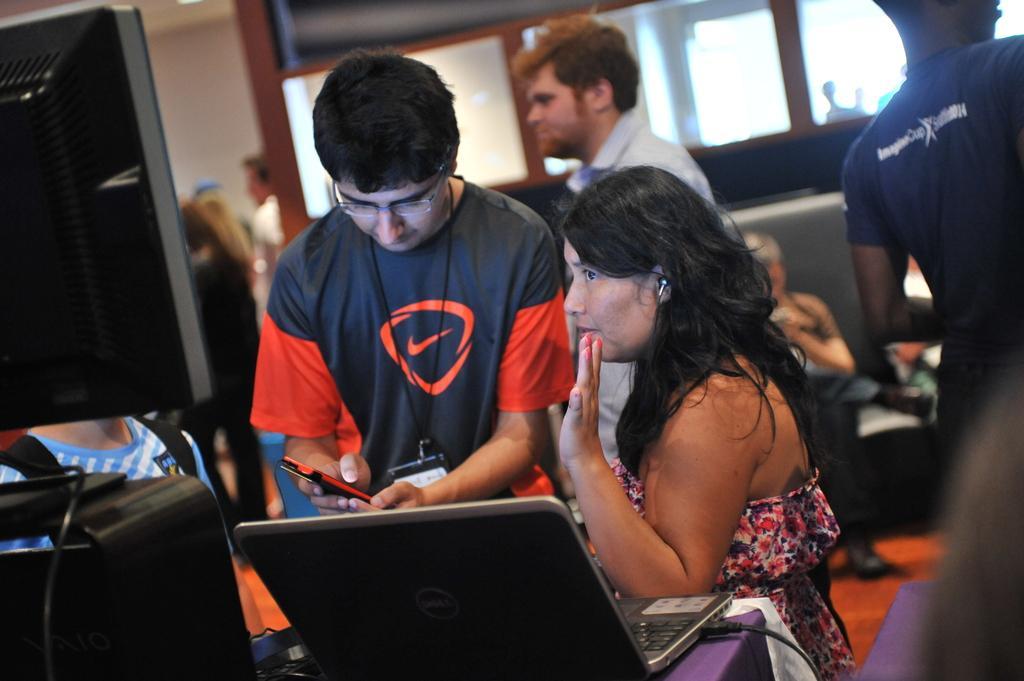In one or two sentences, can you explain what this image depicts? In this image in the front there is a table, on the table there is a laptop, there is a wire and there is an object which is black in colour and there is a monitor. In the center there are persons standing and there is a person standing and holding a mobile phone in his hand. In the background there are persons standing and sitting, there are windows. In the front on the right side there is an object and in the background there is a wall which is white in colour, behind the window there is a person which is visible. 